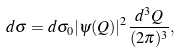Convert formula to latex. <formula><loc_0><loc_0><loc_500><loc_500>d \sigma = d \sigma _ { 0 } | \psi ( Q ) | ^ { 2 } \frac { d ^ { 3 } Q } { ( 2 \pi ) ^ { 3 } } ,</formula> 